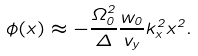<formula> <loc_0><loc_0><loc_500><loc_500>\phi ( x ) \approx - \frac { \Omega _ { 0 } ^ { 2 } } { \Delta } \frac { w _ { 0 } } { v _ { y } } k _ { x } ^ { 2 } x ^ { 2 } .</formula> 